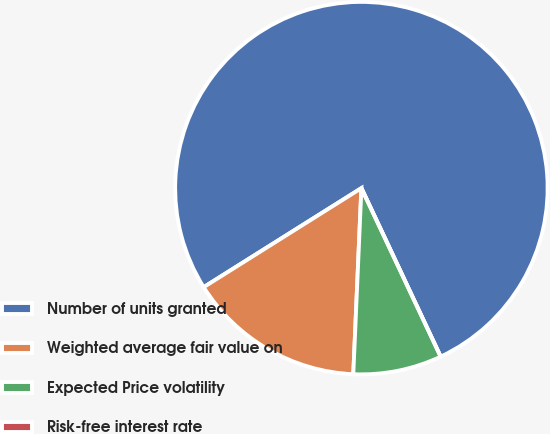Convert chart. <chart><loc_0><loc_0><loc_500><loc_500><pie_chart><fcel>Number of units granted<fcel>Weighted average fair value on<fcel>Expected Price volatility<fcel>Risk-free interest rate<nl><fcel>76.92%<fcel>15.38%<fcel>7.69%<fcel>0.0%<nl></chart> 